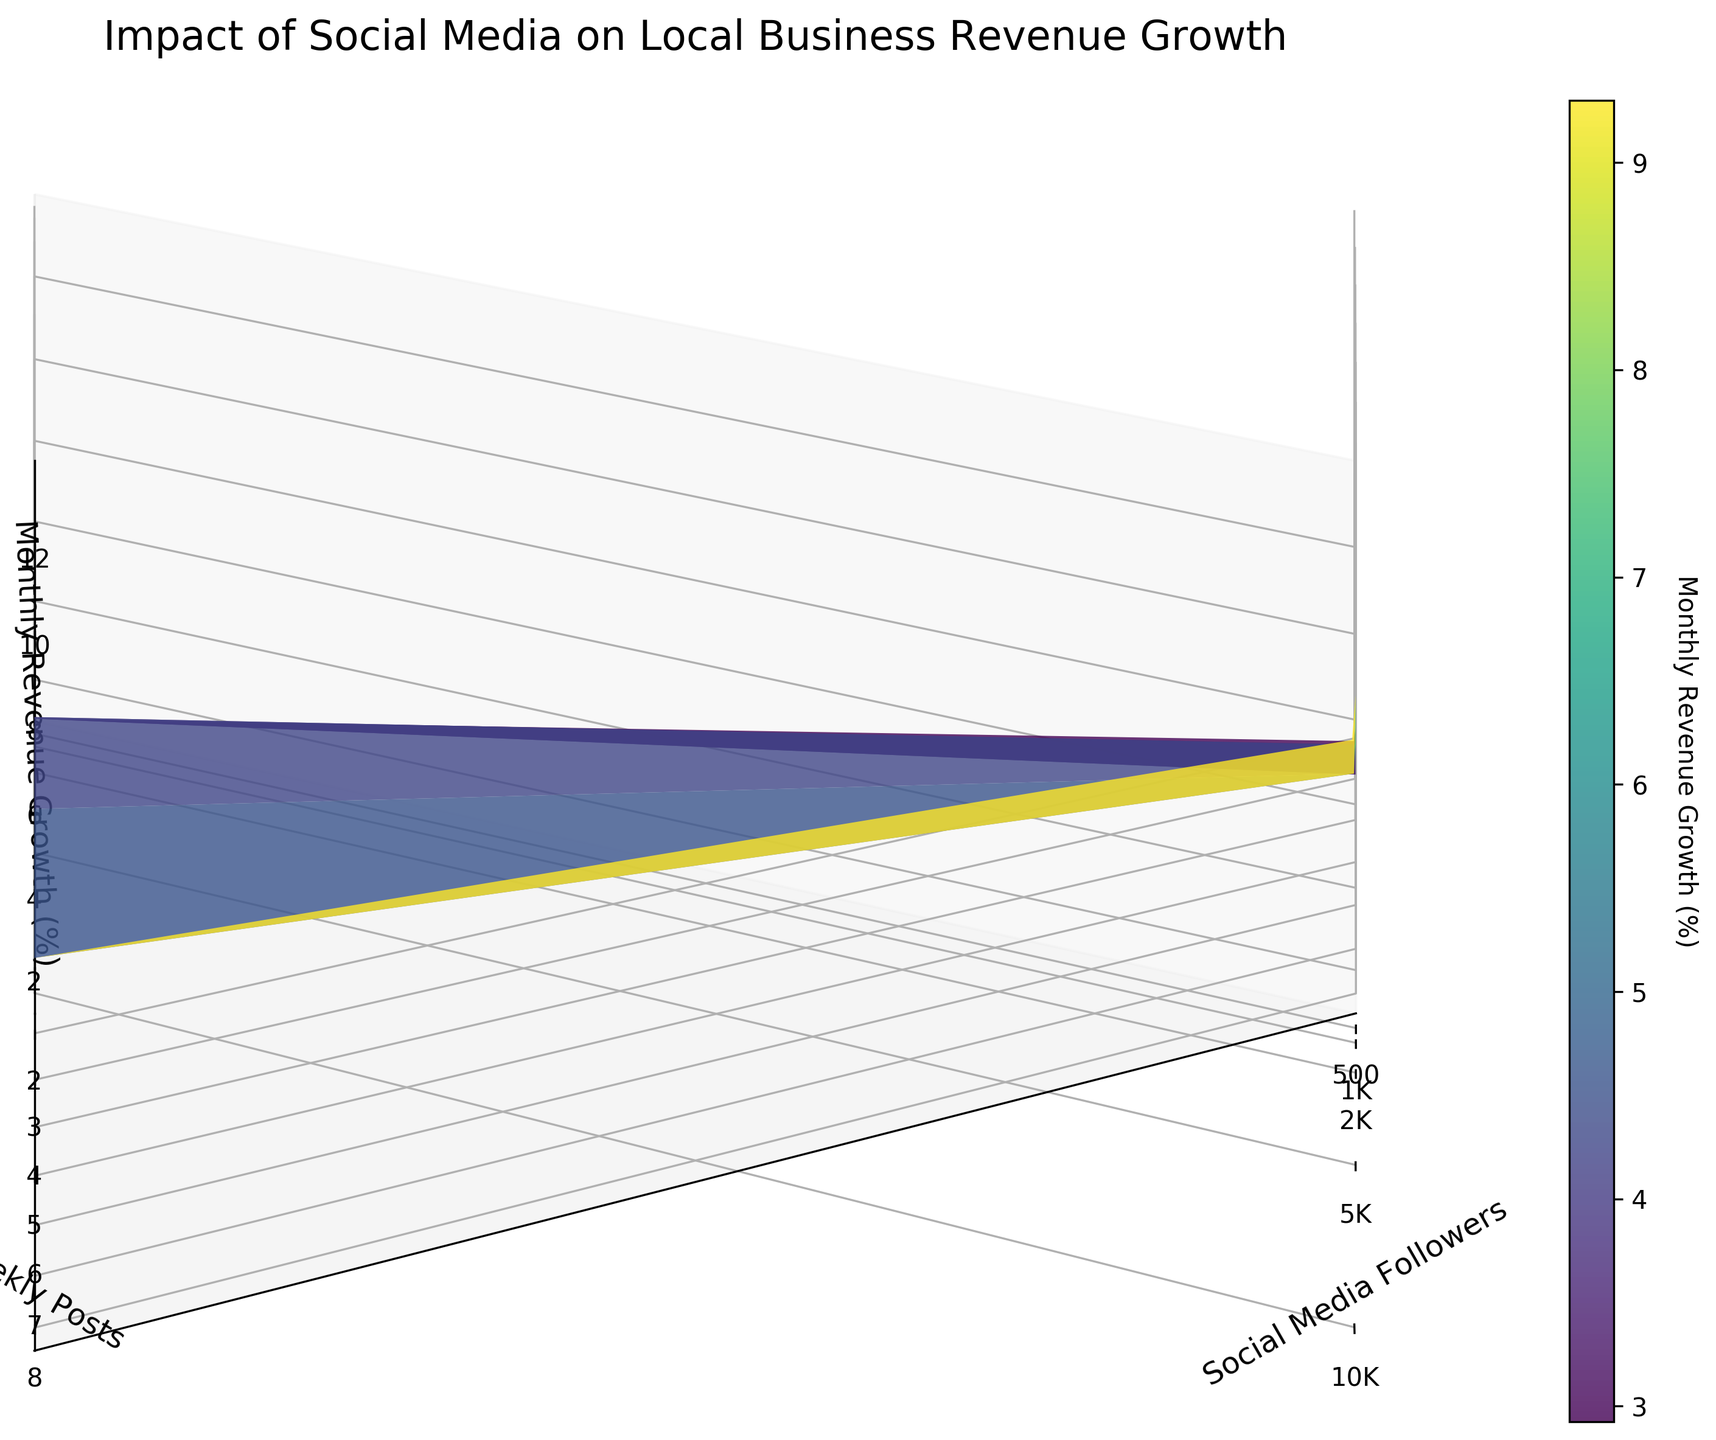What's the title of the figure? The title of the figure is located at the top of the plot and summarizes what the plot is about. It's labeled "Impact of Social Media on Local Business Revenue Growth".
Answer: Impact of Social Media on Local Business Revenue Growth What are the axes labels? The labels for the axes can be found next to each axis. The x-axis is labeled "Social Media Followers", the y-axis is labeled "Weekly Posts", and the z-axis is labeled "Monthly Revenue Growth (%)".
Answer: Social Media Followers, Weekly Posts, Monthly Revenue Growth (%) How does the monthly revenue growth change as social media followers increase? As you look along the x-axis from lower to higher values of social media followers, the z-axis values (monthly revenue growth) also increase. This indicates a positive correlation. For instance, increasing followers from 500 to 5000 shows an increase in revenue growth percentages.
Answer: It increases What pattern do you observe regarding the impact of weekly posts on monthly revenue growth? Observing the y-axis, as the number of weekly posts increases from 2 to 8, the z-axis values (monthly revenue growth) also increase. This suggests positive growth in revenue with more frequent posts at each level of followers.
Answer: More posts correlate with higher revenue growth Which combination of social media followers and weekly posts yields the highest revenue growth? The highest revenue growth is identified at the peak of the surface plot. The maximum z-value occurs at 10K followers and 8 weekly posts, reaching around 13.7%.
Answer: 10K followers, 8 weekly posts Compare the revenue growth for 5K followers with 5 weekly posts to 5K followers with 8 weekly posts. Which is higher? To find this, compare the z-values along the line where x = 5K and y = 5 against x = 5K and y = 8. The revenue growth for 5K followers and 5 weekly posts is 7.9%, whereas for 5K followers and 8 weekly posts, it's 9.3%.
Answer: 5K followers with 8 weekly posts Is the relationship between social media followers and monthly revenue growth linear or exponential? The figure uses a logarithmic scale for the x-axis (social media followers), suggesting an exponential relationship. Observing that smaller increments in x (followers) do not linearly correspond to equal increments in z (revenue growth) further supports this.
Answer: Exponential Are there diminishing returns in revenue growth with increased weekly posts for higher follower counts? Observing y-axis changes at higher follower counts (e.g., 10K), even though increasing weekly posts (e.g., from 5 to 8) still increases revenue, the rate of growth appears to slow down compared to initial increments (e.g., from 2 to 5).
Answer: Yes, there are diminishing returns For a business with 1K followers, what is the revenue growth difference between posting 2 times and 8 times a week? For 1K followers, the z-values at 2 weekly posts are 2.5% and at 8 weekly posts are 4.6%. The difference is thus 4.6% - 2.5% = 2.1%.
Answer: 2.1% What is the general trend of revenue growth when comparing the lowest number of followers with the highest number? The z-values show that the revenue growth trend is substantially higher for the highest follower count (10K) compared to the lowest (500). The percentage growth moves from around 1.2% at 500 followers with 2 posts to upwards of 13.7% at 10K followers with 8 posts.
Answer: Growth increases significantly 